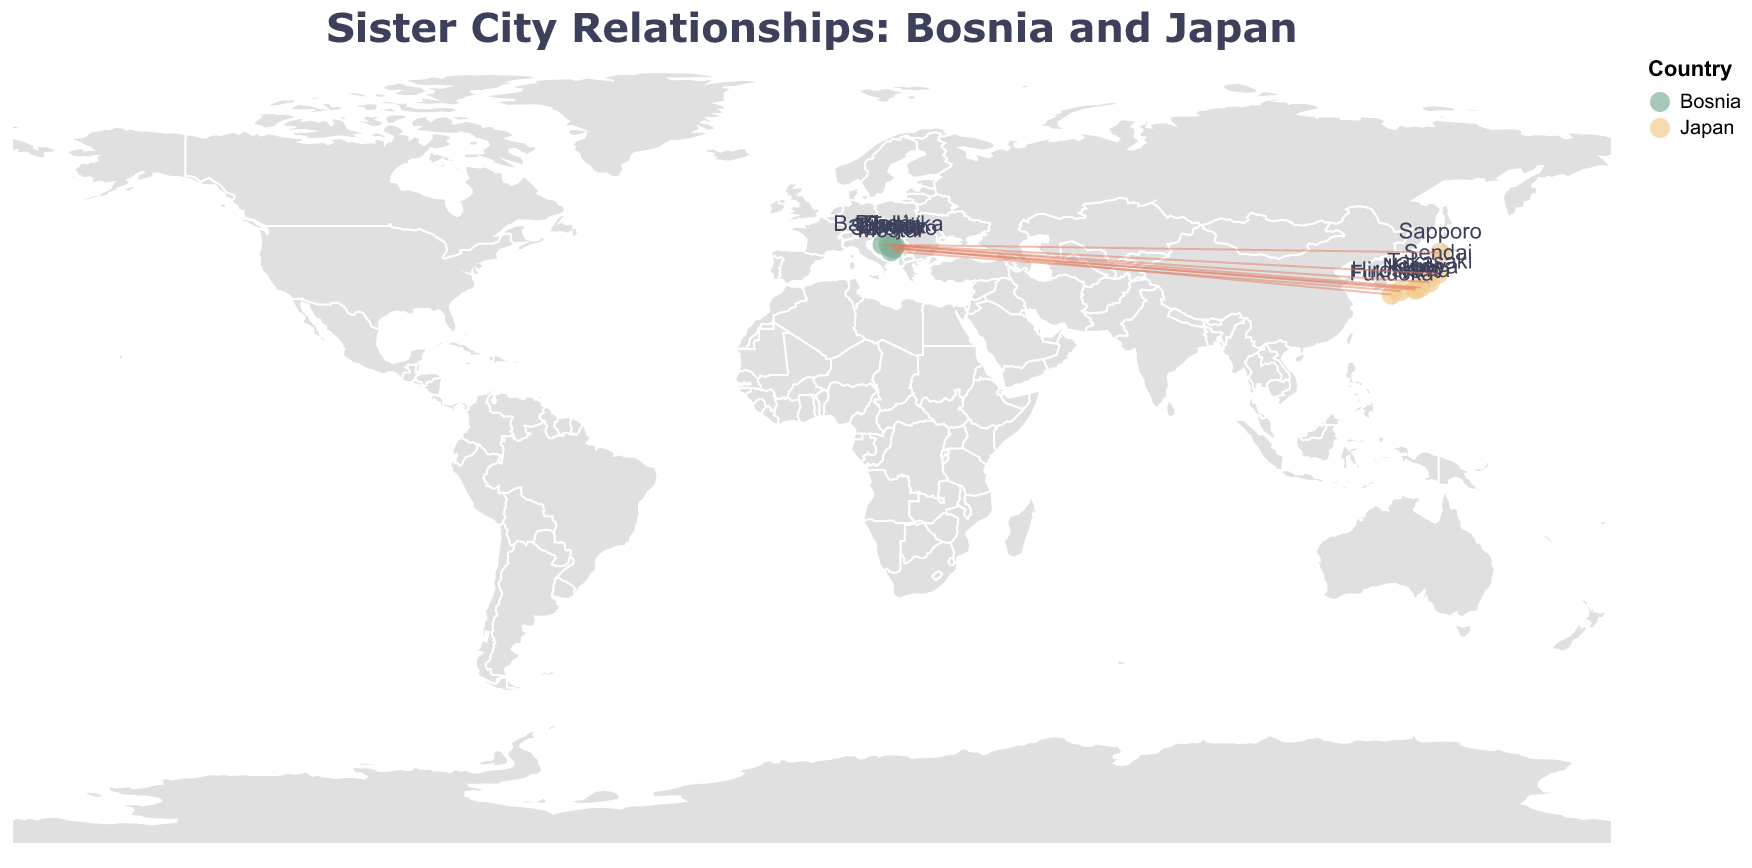What is the title of the figure? The title of the figure is typically found at the top and is usually the most prominent text in the visualization. In this case, it states the main focus of the plot.
Answer: Sister City Relationships: Bosnia and Japan Which Bosnian city is paired with Kyoto? The lines connecting the cities indicate sister city relationships, and the tooltip when hovering shows the relationships. By referring to the cities on the map, we see Sarajevo is connected with Kyoto.
Answer: Sarajevo What type of exchange program exists between Mostar and Hiroshima? The tooltip for the connecting line between Mostar and Hiroshima includes details of the exchange program.
Answer: Peace Memorial Project How many Bosnian cities are represented on the map? The map plots each city with a circle and a label. By counting these for Bosnia, we can find the number of cities.
Answer: 8 Which Japanese city is represented with latitude 36.3219 and longitude 139.0032? To identify the city, look for a point with the mentioned coordinates, or refer to the tooltip information when hovering on the corresponding point.
Answer: Takasaki Which program involves the exchange of students? The tooltip for the lines indicates the type of exchange program between cities. Locating and hovering over the "Student Exchange" will show the related cities.
Answer: Sarajevo and Kyoto Compare the latitude of Sarajevo and Sendai. Which is further north? Sarajevo has a latitude of 43.8563, while Sendai has a latitude of 38.2682. Comparing these values shows which city is further north.
Answer: Sarajevo What type of projection is used in this map? The map type is usually detailed in the figure's description. In this case, it states an "equirectangular" projection.
Answer: Equirectangular Find the pair that participates in the Historical Heritage Program. This can be found through the tooltip information of the lines connecting cities, where the program details are displayed.
Answer: Travnik and Nara Which city in Bosnia has a coordination with a Japanese city related to disaster prevention? Observing the map and looking at the lines' tooltips will reveal that Doboj is connected with Sendai for a Disaster Prevention Workshop.
Answer: Doboj 